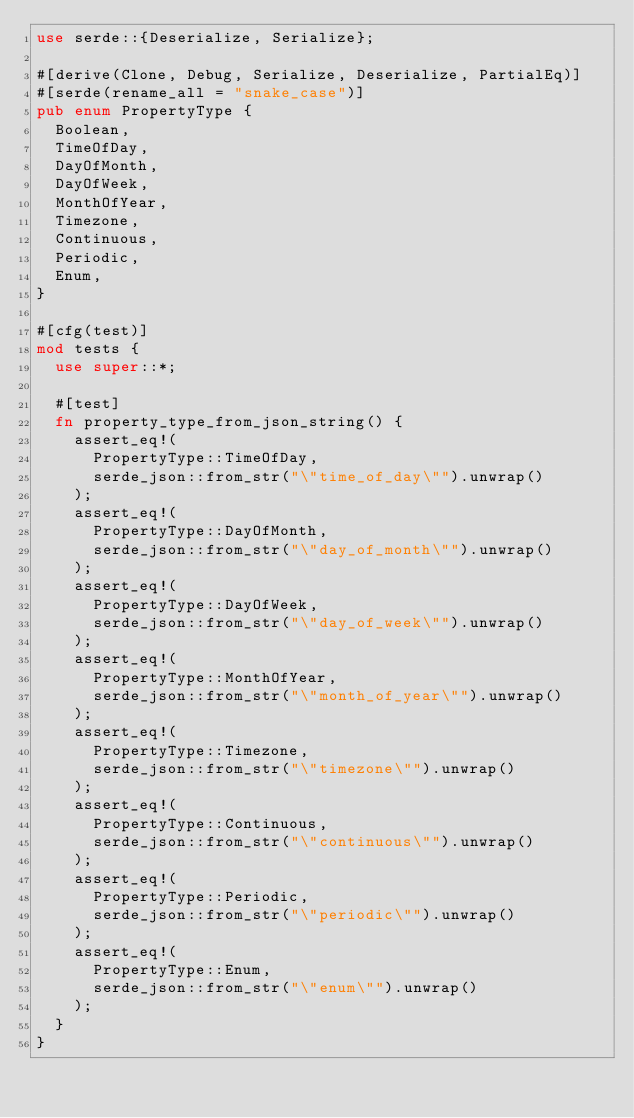<code> <loc_0><loc_0><loc_500><loc_500><_Rust_>use serde::{Deserialize, Serialize};

#[derive(Clone, Debug, Serialize, Deserialize, PartialEq)]
#[serde(rename_all = "snake_case")]
pub enum PropertyType {
  Boolean,
  TimeOfDay,
  DayOfMonth,
  DayOfWeek,
  MonthOfYear,
  Timezone,
  Continuous,
  Periodic,
  Enum,
}

#[cfg(test)]
mod tests {
  use super::*;

  #[test]
  fn property_type_from_json_string() {
    assert_eq!(
      PropertyType::TimeOfDay,
      serde_json::from_str("\"time_of_day\"").unwrap()
    );
    assert_eq!(
      PropertyType::DayOfMonth,
      serde_json::from_str("\"day_of_month\"").unwrap()
    );
    assert_eq!(
      PropertyType::DayOfWeek,
      serde_json::from_str("\"day_of_week\"").unwrap()
    );
    assert_eq!(
      PropertyType::MonthOfYear,
      serde_json::from_str("\"month_of_year\"").unwrap()
    );
    assert_eq!(
      PropertyType::Timezone,
      serde_json::from_str("\"timezone\"").unwrap()
    );
    assert_eq!(
      PropertyType::Continuous,
      serde_json::from_str("\"continuous\"").unwrap()
    );
    assert_eq!(
      PropertyType::Periodic,
      serde_json::from_str("\"periodic\"").unwrap()
    );
    assert_eq!(
      PropertyType::Enum,
      serde_json::from_str("\"enum\"").unwrap()
    );
  }
}
</code> 